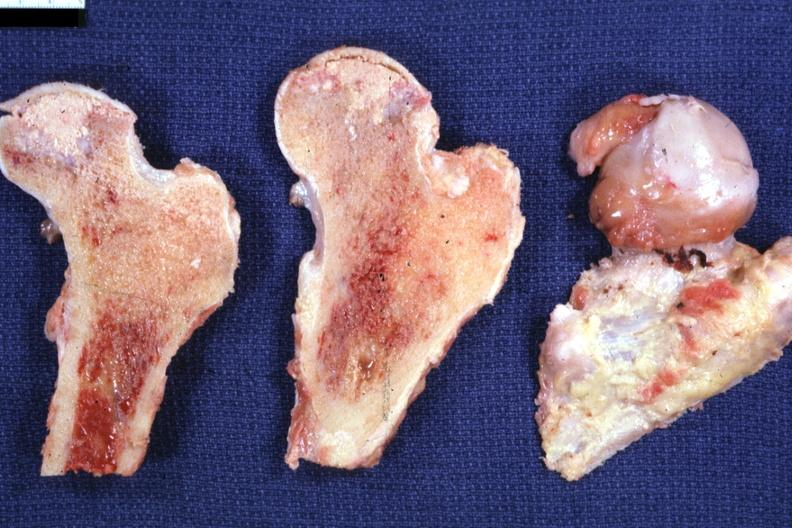s joints present?
Answer the question using a single word or phrase. Yes 